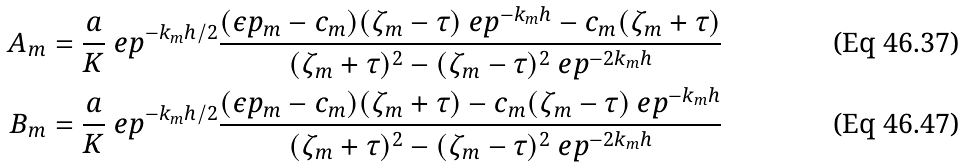Convert formula to latex. <formula><loc_0><loc_0><loc_500><loc_500>A _ { m } & = \frac { a } { K } \ e p ^ { - k _ { m } h / 2 } \frac { ( \epsilon p _ { m } - c _ { m } ) ( \zeta _ { m } - \tau ) \ e p ^ { - k _ { m } h } - c _ { m } ( \zeta _ { m } + \tau ) } { ( \zeta _ { m } + \tau ) ^ { 2 } - ( \zeta _ { m } - \tau ) ^ { 2 } \ e p ^ { - 2 k _ { m } h } } \\ B _ { m } & = \frac { a } { K } \ e p ^ { - k _ { m } h / 2 } \frac { ( \epsilon p _ { m } - c _ { m } ) ( \zeta _ { m } + \tau ) - c _ { m } ( \zeta _ { m } - \tau ) \ e p ^ { - k _ { m } h } } { ( \zeta _ { m } + \tau ) ^ { 2 } - ( \zeta _ { m } - \tau ) ^ { 2 } \ e p ^ { - 2 k _ { m } h } }</formula> 